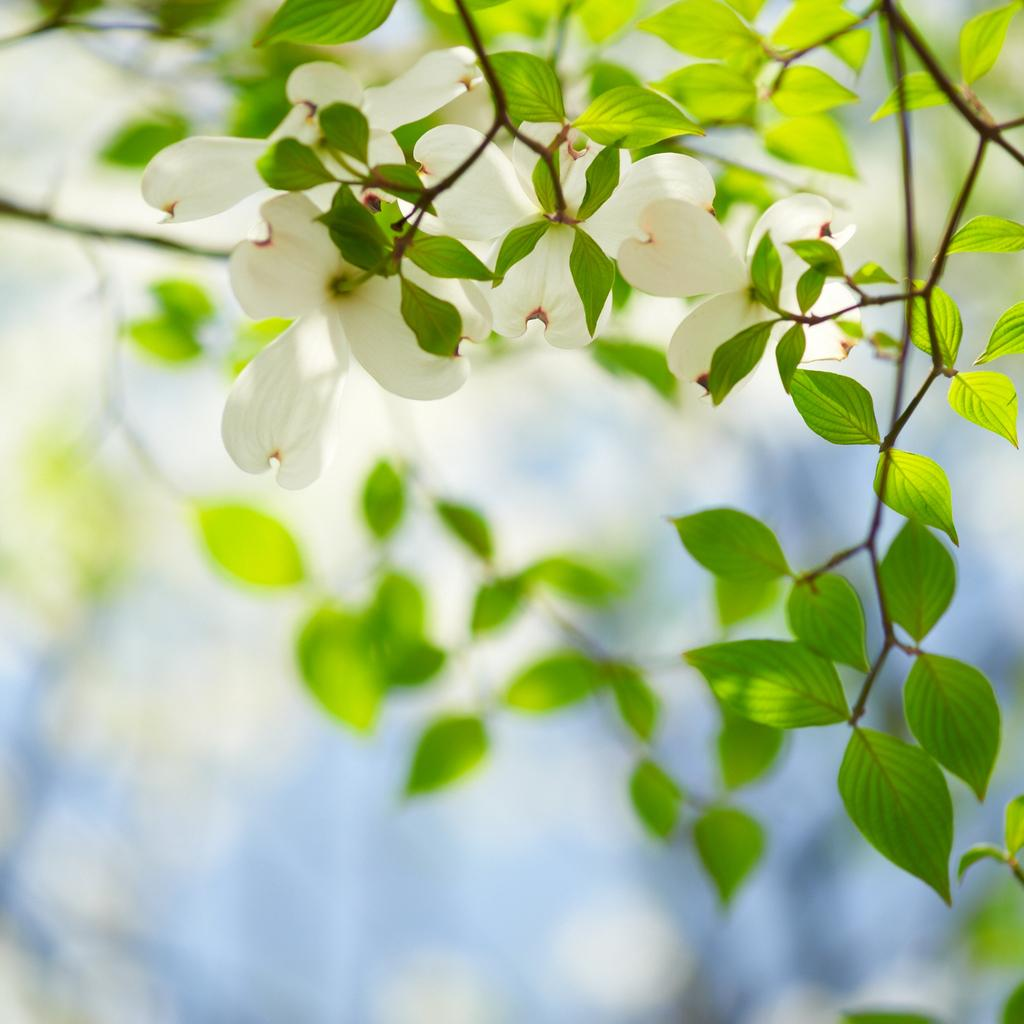What type of flowers can be seen in the image? There are white color flowers in the image. What is the color of the leaves in the image? The leaves in the image are green. Where is the cherry placed in the image? There is no cherry present in the image. What type of brake can be seen in the image? There is no brake present in the image. 